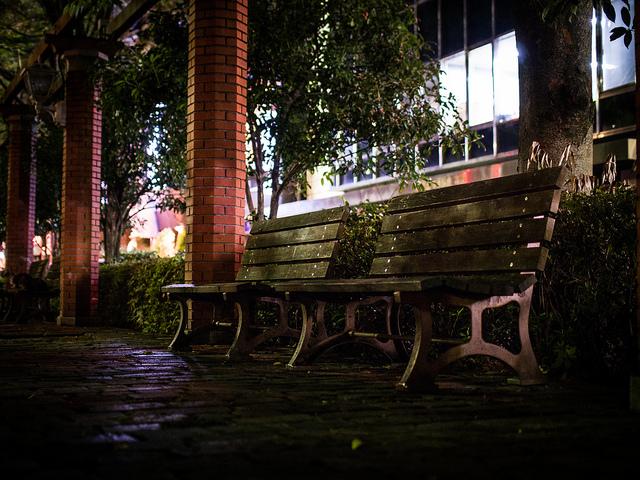How many benches are on the right?
Quick response, please. 2. IS there a fence in this pic?
Concise answer only. No. Is this an old photo?
Give a very brief answer. No. Is it sunny outside?
Short answer required. No. Are there people sitting on the bench?
Answer briefly. No. Are the benches joined together?
Give a very brief answer. No. What are the benches frames made of?
Keep it brief. Wood. Is there a cop riding a horse in the park?
Write a very short answer. No. What are the columns made out of?
Give a very brief answer. Brick. How long are the benches?
Keep it brief. 4 feet. How many people are sitting?
Quick response, please. 0. How many cows are stacked?
Write a very short answer. 0. 